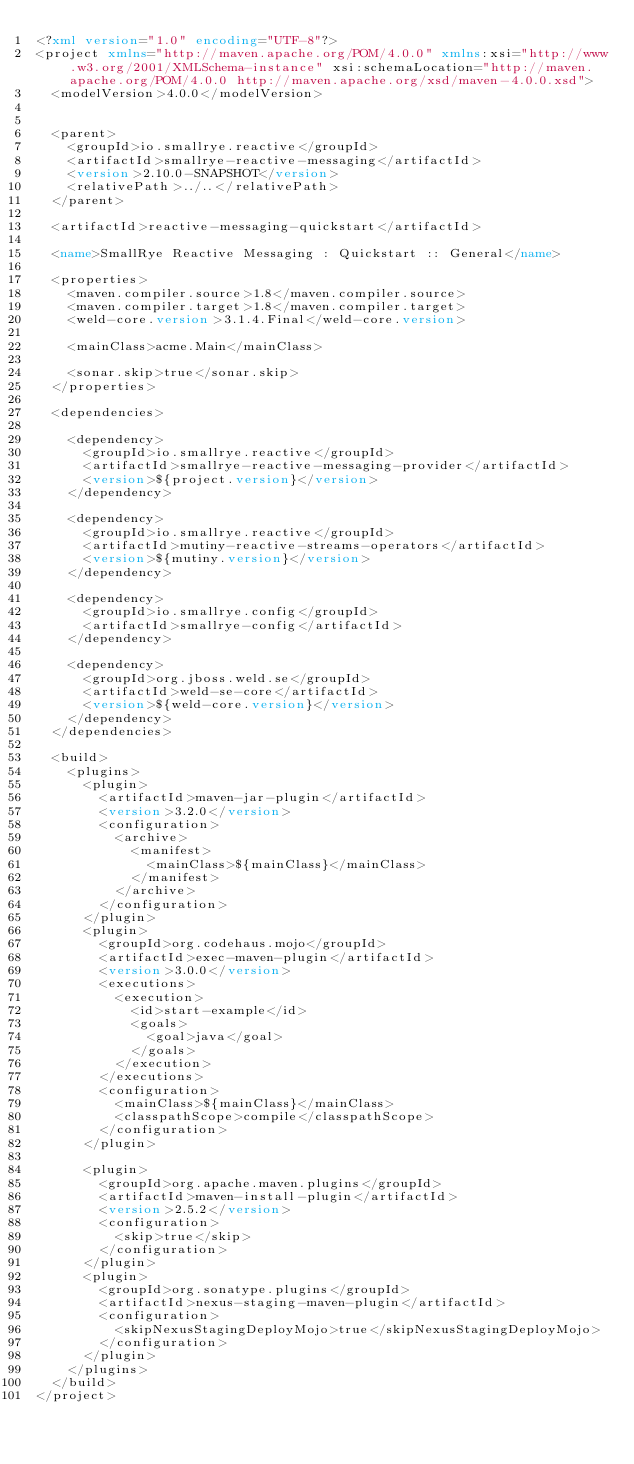Convert code to text. <code><loc_0><loc_0><loc_500><loc_500><_XML_><?xml version="1.0" encoding="UTF-8"?>
<project xmlns="http://maven.apache.org/POM/4.0.0" xmlns:xsi="http://www.w3.org/2001/XMLSchema-instance" xsi:schemaLocation="http://maven.apache.org/POM/4.0.0 http://maven.apache.org/xsd/maven-4.0.0.xsd">
  <modelVersion>4.0.0</modelVersion>


  <parent>
    <groupId>io.smallrye.reactive</groupId>
    <artifactId>smallrye-reactive-messaging</artifactId>
    <version>2.10.0-SNAPSHOT</version>
    <relativePath>../..</relativePath>
  </parent>

  <artifactId>reactive-messaging-quickstart</artifactId>

  <name>SmallRye Reactive Messaging : Quickstart :: General</name>

  <properties>
    <maven.compiler.source>1.8</maven.compiler.source>
    <maven.compiler.target>1.8</maven.compiler.target>
    <weld-core.version>3.1.4.Final</weld-core.version>

    <mainClass>acme.Main</mainClass>

    <sonar.skip>true</sonar.skip>
  </properties>

  <dependencies>

    <dependency>
      <groupId>io.smallrye.reactive</groupId>
      <artifactId>smallrye-reactive-messaging-provider</artifactId>
      <version>${project.version}</version>
    </dependency>

    <dependency>
      <groupId>io.smallrye.reactive</groupId>
      <artifactId>mutiny-reactive-streams-operators</artifactId>
      <version>${mutiny.version}</version>
    </dependency>

    <dependency>
      <groupId>io.smallrye.config</groupId>
      <artifactId>smallrye-config</artifactId>
    </dependency>

    <dependency>
      <groupId>org.jboss.weld.se</groupId>
      <artifactId>weld-se-core</artifactId>
      <version>${weld-core.version}</version>
    </dependency>
  </dependencies>

  <build>
    <plugins>
      <plugin>
        <artifactId>maven-jar-plugin</artifactId>
        <version>3.2.0</version>
        <configuration>
          <archive>
            <manifest>
              <mainClass>${mainClass}</mainClass>
            </manifest>
          </archive>
        </configuration>
      </plugin>
      <plugin>
        <groupId>org.codehaus.mojo</groupId>
        <artifactId>exec-maven-plugin</artifactId>
        <version>3.0.0</version>
        <executions>
          <execution>
            <id>start-example</id>
            <goals>
              <goal>java</goal>
            </goals>
          </execution>
        </executions>
        <configuration>
          <mainClass>${mainClass}</mainClass>
          <classpathScope>compile</classpathScope>
        </configuration>
      </plugin>

      <plugin>
        <groupId>org.apache.maven.plugins</groupId>
        <artifactId>maven-install-plugin</artifactId>
        <version>2.5.2</version>
        <configuration>
          <skip>true</skip>
        </configuration>
      </plugin>
      <plugin>
        <groupId>org.sonatype.plugins</groupId>
        <artifactId>nexus-staging-maven-plugin</artifactId>
        <configuration>
          <skipNexusStagingDeployMojo>true</skipNexusStagingDeployMojo>
        </configuration>
      </plugin>
    </plugins>
  </build>
</project>
</code> 